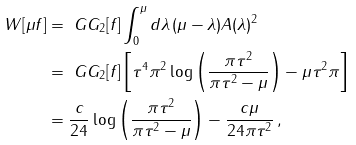<formula> <loc_0><loc_0><loc_500><loc_500>W [ \mu f ] & = \ G G _ { 2 } [ f ] \int _ { 0 } ^ { \mu } d \lambda \, ( \mu - \lambda ) A ( \lambda ) ^ { 2 } \\ & = \ G G _ { 2 } [ f ] \left [ \tau ^ { 4 } \pi ^ { 2 } \log \left ( \frac { \pi \tau ^ { 2 } } { \pi \tau ^ { 2 } - \mu } \right ) - \mu \tau ^ { 2 } \pi \right ] \\ & = \frac { c } { 2 4 } \log \left ( \frac { \pi \tau ^ { 2 } } { \pi \tau ^ { 2 } - \mu } \right ) - \frac { c \mu } { 2 4 \pi \tau ^ { 2 } } \, ,</formula> 